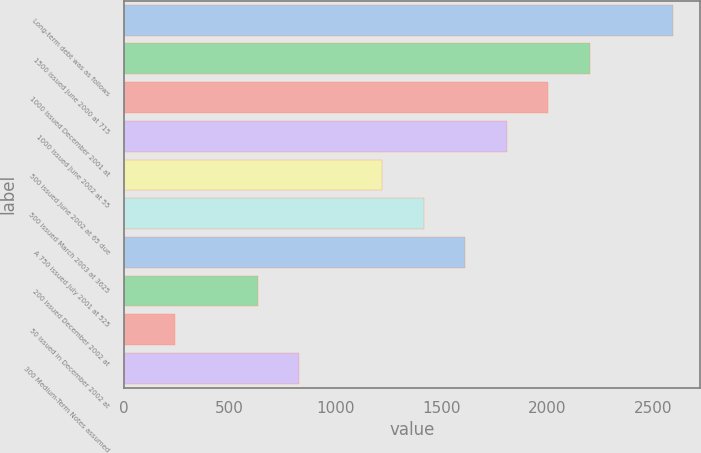Convert chart to OTSL. <chart><loc_0><loc_0><loc_500><loc_500><bar_chart><fcel>Long-term debt was as follows<fcel>1500 issued June 2000 at 715<fcel>1000 issued December 2001 at<fcel>1000 issued June 2002 at 55<fcel>500 issued June 2002 at 65 due<fcel>500 issued March 2003 at 3625<fcel>A 750 issued July 2001 at 525<fcel>200 issued December 2002 at<fcel>50 issued in December 2002 at<fcel>300 Medium-Term Notes assumed<nl><fcel>2592<fcel>2200<fcel>2004<fcel>1808<fcel>1220<fcel>1416<fcel>1612<fcel>632<fcel>240<fcel>828<nl></chart> 